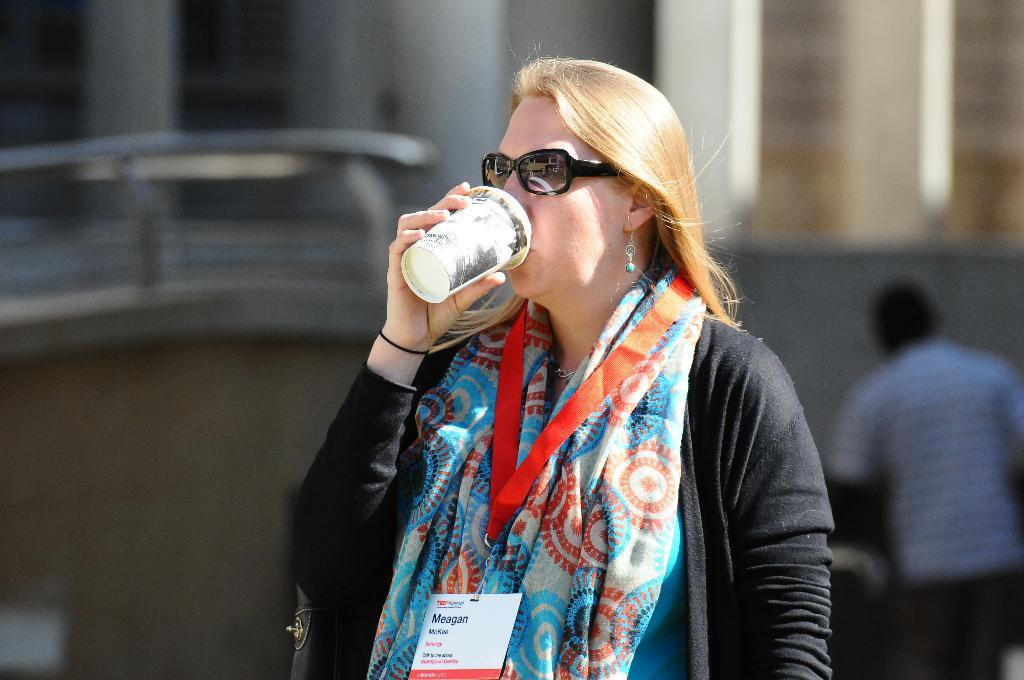Who is the main subject in the image? There is a woman in the image. What is the woman doing in the image? The woman is drinking something. What protective gear is the woman wearing? The woman is wearing goggles. What identification is visible on the woman? There is an identity card around the woman's neck. How is the background of the image depicted? The background of the woman is blurred. What star is the woman's grandfather pointing to in the image? There is no star or grandfather present in the image. On which side of the woman is the identity card located? The identity card is located around the woman's neck, not on her side. 